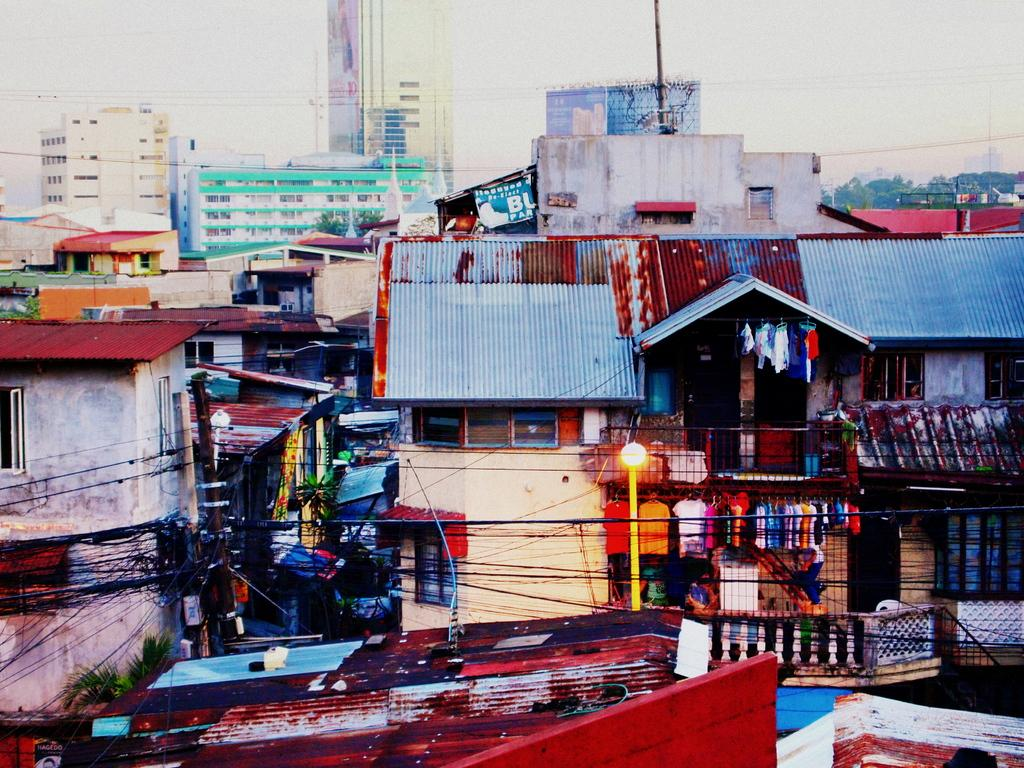What type of structures can be seen in the image? There are buildings with windows in the image. What other objects can be seen in the image? There are wires, poles, hoardings, clothes on hangers, trees, and various other objects in the image. What is visible in the background of the image? The sky is visible in the background of the image. How does the lamp create friction in the image? There is no lamp present in the image, so it is not possible to determine how it might create friction. 